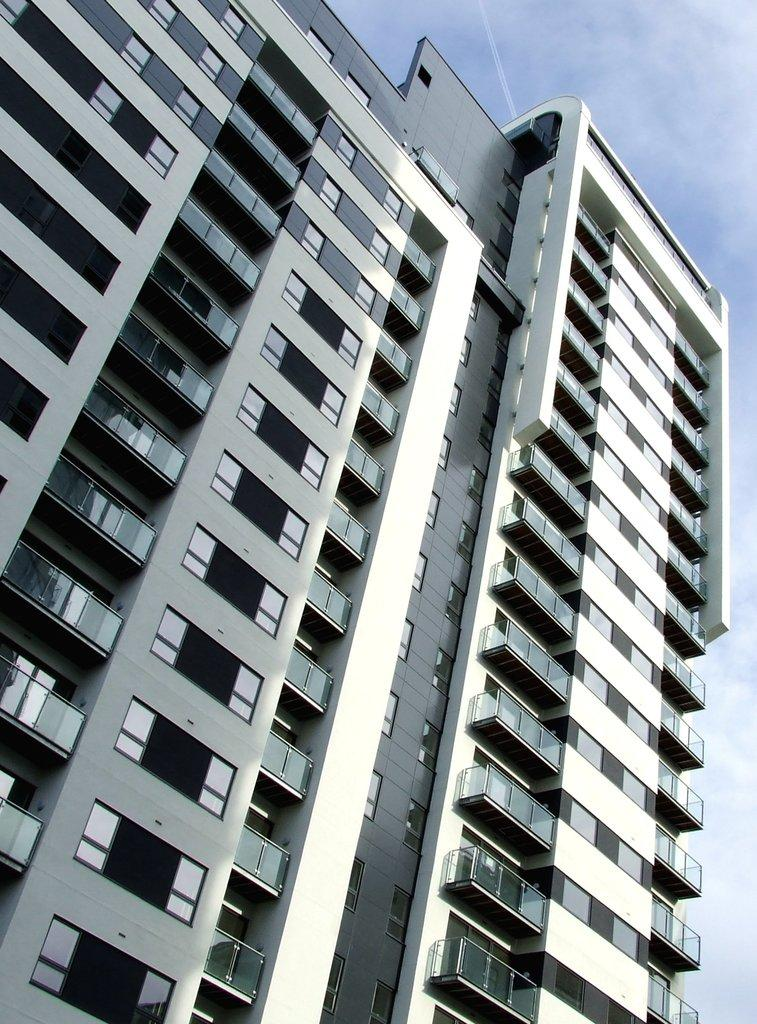What is the main subject of the picture? The main subject of the picture is a building. Are there any specific features of the building? Yes, the building has glass elements on it. Can you tell me how many eyes are visible on the building in the image? There are no eyes visible on the building in the image. What type of crack can be seen on the glass elements of the building? There is no crack visible on the glass elements of the building in the image. 